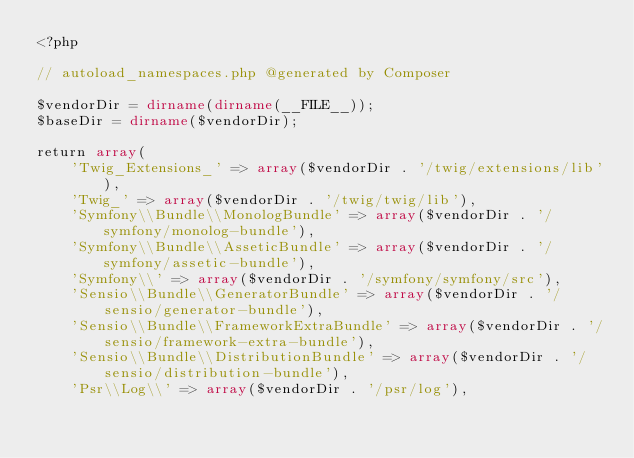<code> <loc_0><loc_0><loc_500><loc_500><_PHP_><?php

// autoload_namespaces.php @generated by Composer

$vendorDir = dirname(dirname(__FILE__));
$baseDir = dirname($vendorDir);

return array(
    'Twig_Extensions_' => array($vendorDir . '/twig/extensions/lib'),
    'Twig_' => array($vendorDir . '/twig/twig/lib'),
    'Symfony\\Bundle\\MonologBundle' => array($vendorDir . '/symfony/monolog-bundle'),
    'Symfony\\Bundle\\AsseticBundle' => array($vendorDir . '/symfony/assetic-bundle'),
    'Symfony\\' => array($vendorDir . '/symfony/symfony/src'),
    'Sensio\\Bundle\\GeneratorBundle' => array($vendorDir . '/sensio/generator-bundle'),
    'Sensio\\Bundle\\FrameworkExtraBundle' => array($vendorDir . '/sensio/framework-extra-bundle'),
    'Sensio\\Bundle\\DistributionBundle' => array($vendorDir . '/sensio/distribution-bundle'),
    'Psr\\Log\\' => array($vendorDir . '/psr/log'),</code> 